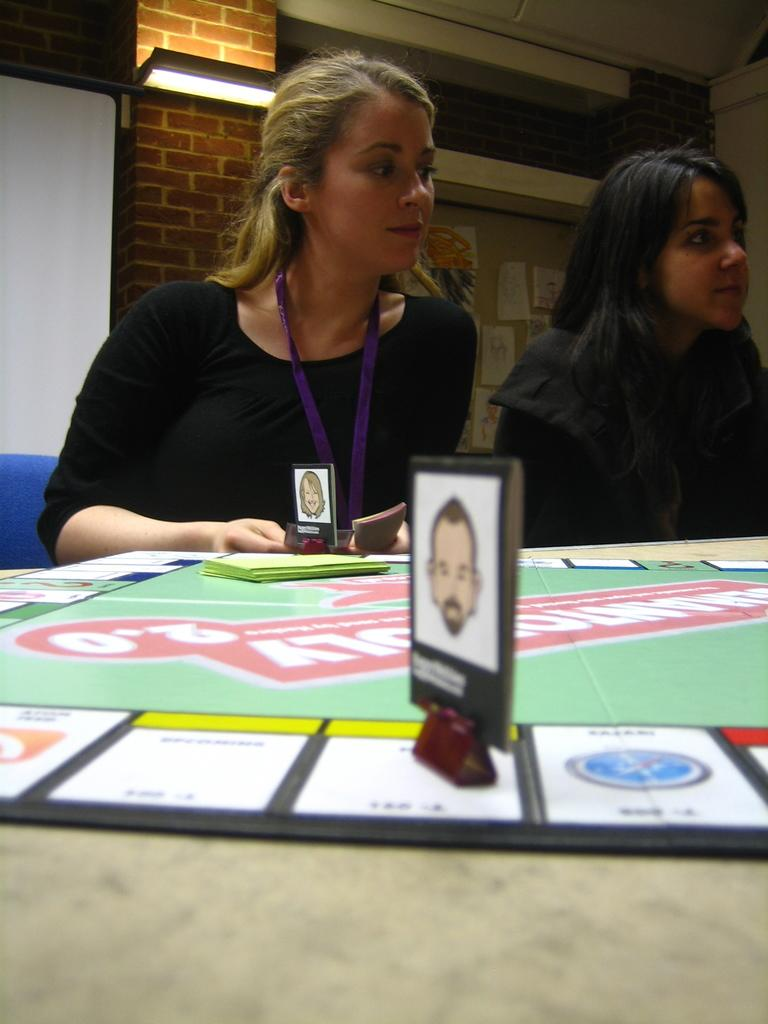How many people are in the image? There are two persons in the image. What are the persons doing in the image? The persons are sitting on chairs. What is the arrangement of the chairs in the image? The chairs are around a table. What objects can be seen on the table? There are cards and papers on the table. What can be seen in the background of the image? There is a brick wall, another table, and a light source in the background. Can you tell me how many times the goose bites the person in the image? There is no goose or biting in the image; it features two persons sitting around a table with cards and papers. What type of liquid is being poured from the light source in the image? There is no liquid or pouring action depicted in the image; the light source is simply a background element. 